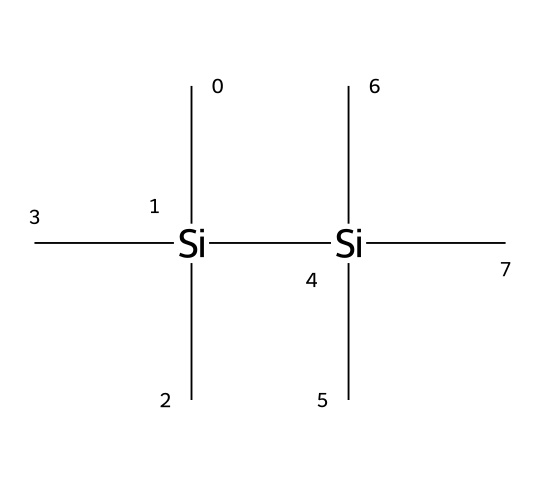What is the name of this chemical? The SMILES representation corresponds to hexamethyldisilane, which is a silane compound characterized by having two silicon atoms bonded to three methyl groups each.
Answer: hexamethyldisilane How many silicon atoms are present in the structure? The SMILES notation shows two silicon (Si) atoms, as indicated by the 'Si' directly present in the structure.
Answer: two How many carbon atoms are in hexamethyldisilane? By analyzing the SMILES, there are a total of six carbon (C) atoms around the silicon atoms, as each silicon atom is bonded to three methyl groups (each containing one carbon).
Answer: six What type of chemical compound is hexamethyldisilane classified as? Hexamethyldisilane is classified as a silane, which is a derivative of silicon that features silicon-to-carbon bonds.
Answer: silane How does hexamethyldisilane contribute to waterproofing fabrics? The chemical’s structure allows it to form a protective layer on the fabric, providing hydrophobic properties due to the presence of methyl groups, which repel water.
Answer: hydrophobic What type of bonding is primarily present in hexamethyldisilane? The primary bonding in hexamethyldisilane involves covalent bonds, which are formed between silicon and carbon atoms as well as between silicon atoms themselves.
Answer: covalent 